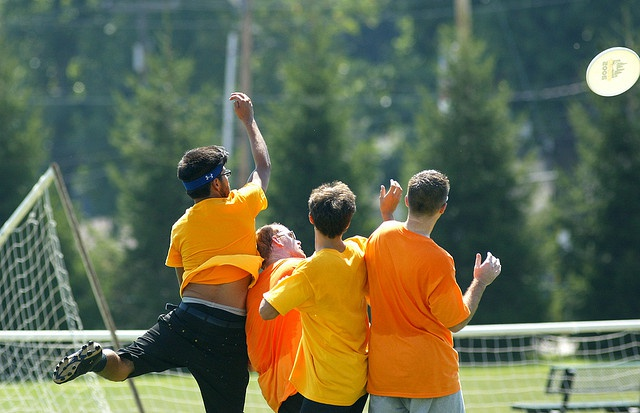Describe the objects in this image and their specific colors. I can see people in gray, black, and orange tones, people in gray, red, and black tones, people in gray, orange, and black tones, people in gray, red, ivory, and black tones, and frisbee in gray, beige, and teal tones in this image. 